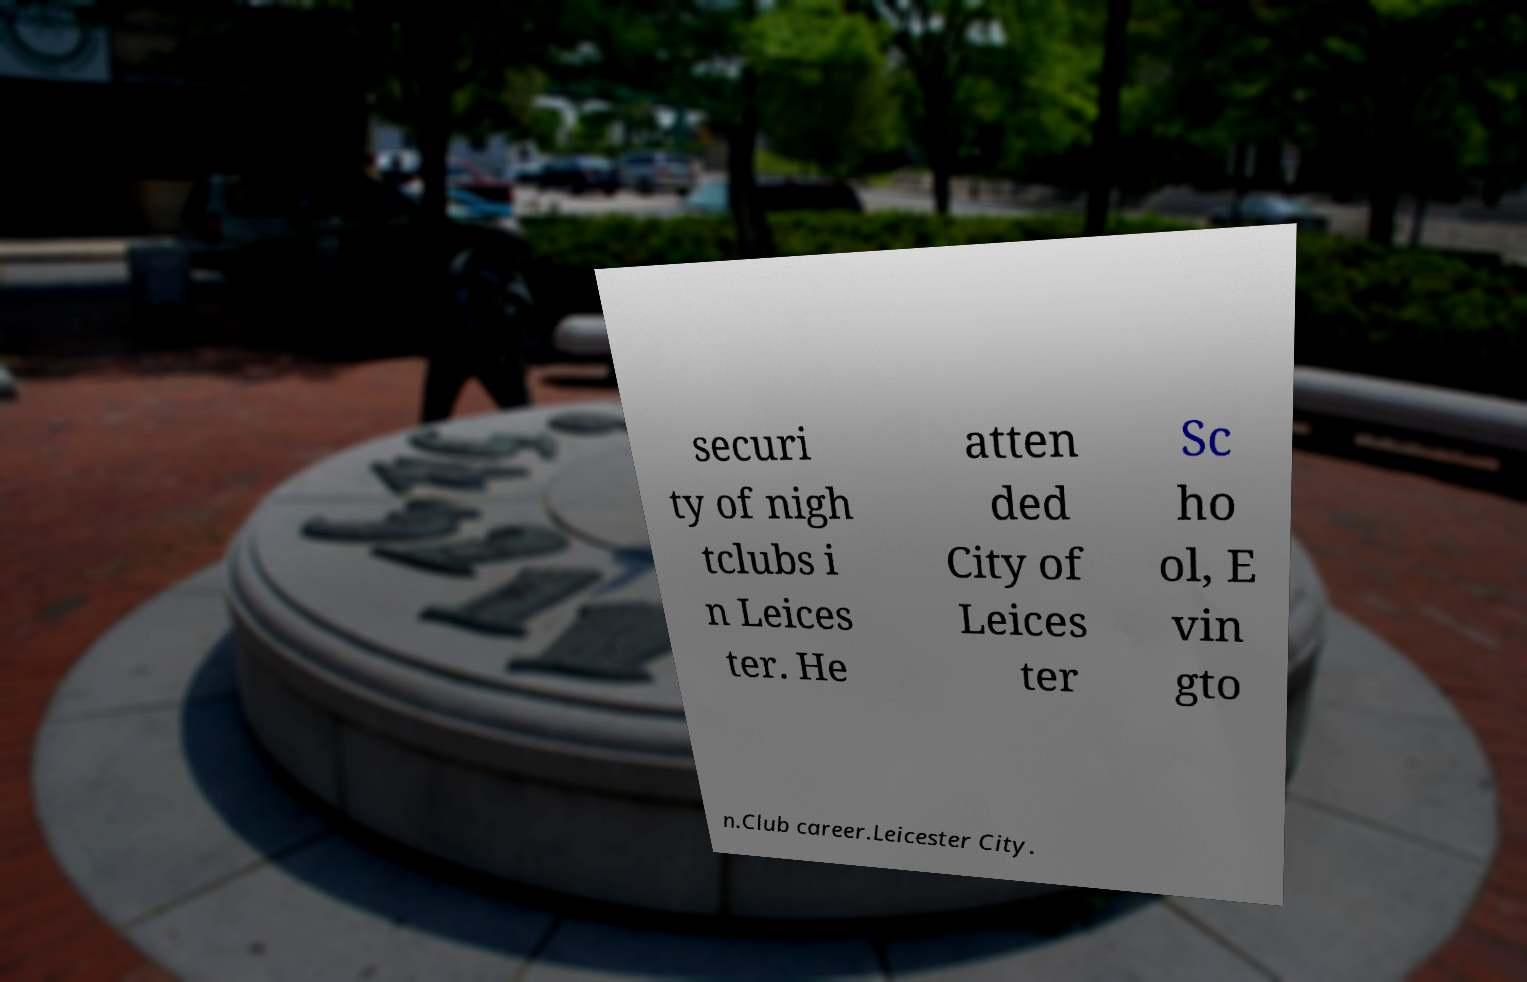Can you accurately transcribe the text from the provided image for me? securi ty of nigh tclubs i n Leices ter. He atten ded City of Leices ter Sc ho ol, E vin gto n.Club career.Leicester City. 